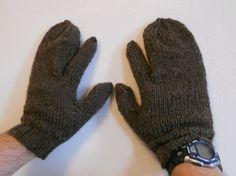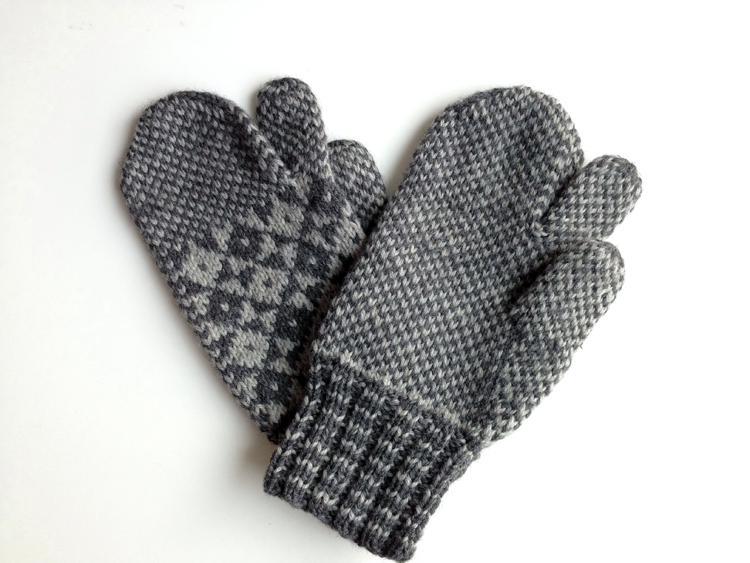The first image is the image on the left, the second image is the image on the right. Examine the images to the left and right. Is the description "Only the right image shows mittens with a diamond pattern." accurate? Answer yes or no. Yes. 